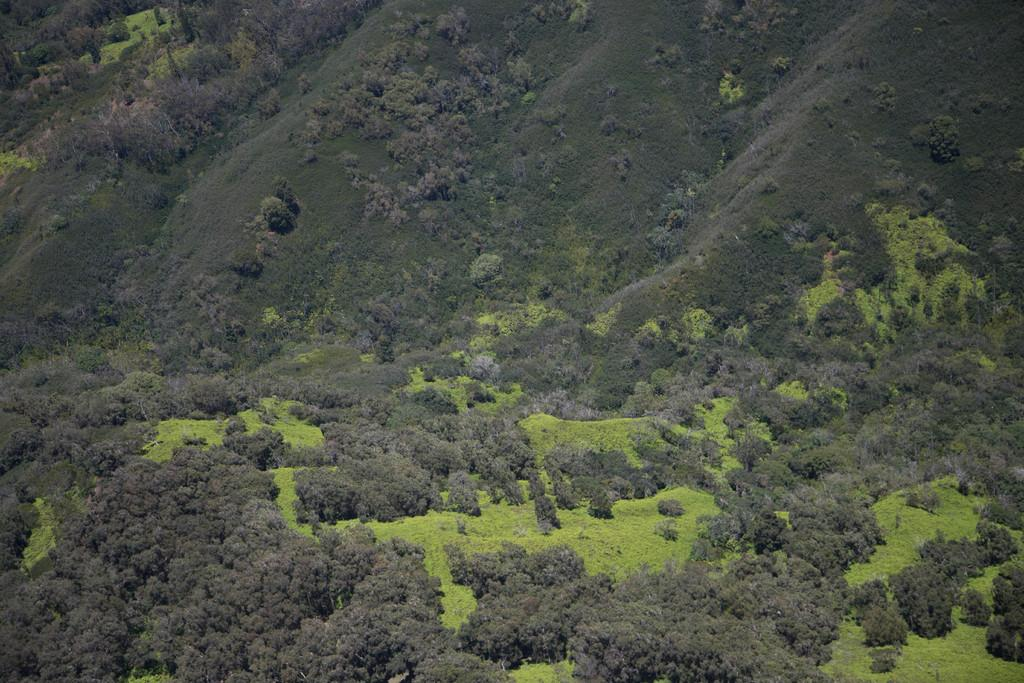What type of vegetation is present in the image? There are plenty of trees and plants in the image. Can you describe the density of the vegetation in the image? Yes, there are plenty of trees and plants visible in the image. What type of trip can be seen being offered by the branch in the image? There is no trip or branch present in the image; it only features trees and plants. 